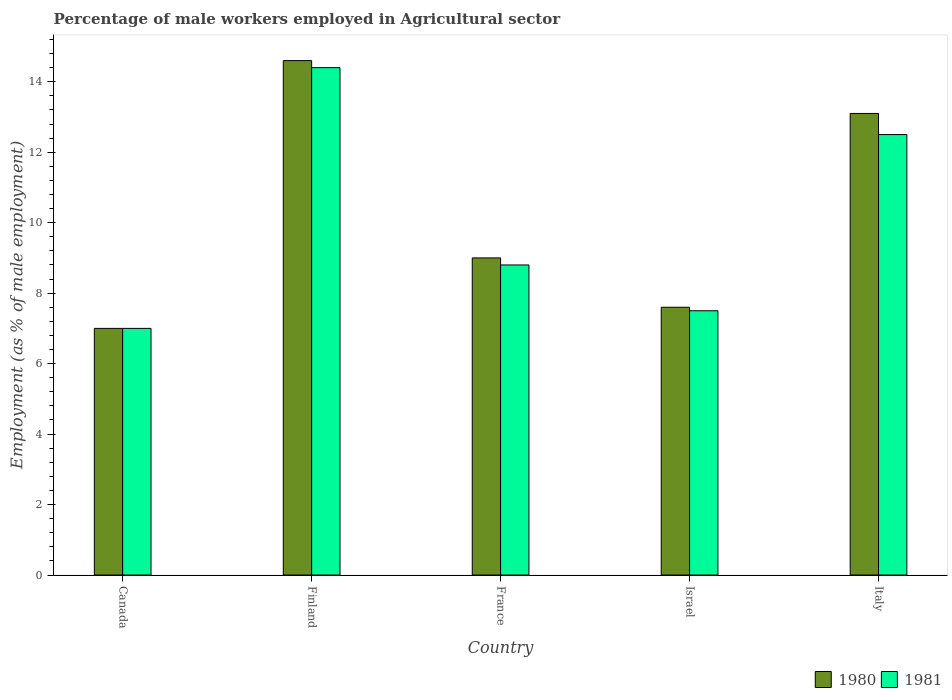How many different coloured bars are there?
Provide a succinct answer. 2. Are the number of bars per tick equal to the number of legend labels?
Provide a succinct answer. Yes. Are the number of bars on each tick of the X-axis equal?
Your answer should be compact. Yes. How many bars are there on the 2nd tick from the left?
Give a very brief answer. 2. How many bars are there on the 3rd tick from the right?
Keep it short and to the point. 2. In how many cases, is the number of bars for a given country not equal to the number of legend labels?
Make the answer very short. 0. Across all countries, what is the maximum percentage of male workers employed in Agricultural sector in 1980?
Your response must be concise. 14.6. In which country was the percentage of male workers employed in Agricultural sector in 1981 maximum?
Make the answer very short. Finland. What is the total percentage of male workers employed in Agricultural sector in 1981 in the graph?
Your answer should be compact. 50.2. What is the difference between the percentage of male workers employed in Agricultural sector in 1980 in Canada and that in France?
Offer a terse response. -2. What is the difference between the percentage of male workers employed in Agricultural sector in 1980 in Israel and the percentage of male workers employed in Agricultural sector in 1981 in Italy?
Give a very brief answer. -4.9. What is the average percentage of male workers employed in Agricultural sector in 1980 per country?
Your answer should be compact. 10.26. What is the difference between the percentage of male workers employed in Agricultural sector of/in 1981 and percentage of male workers employed in Agricultural sector of/in 1980 in Italy?
Your answer should be compact. -0.6. In how many countries, is the percentage of male workers employed in Agricultural sector in 1981 greater than 0.8 %?
Ensure brevity in your answer.  5. What is the ratio of the percentage of male workers employed in Agricultural sector in 1981 in France to that in Israel?
Keep it short and to the point. 1.17. What is the difference between the highest and the second highest percentage of male workers employed in Agricultural sector in 1980?
Ensure brevity in your answer.  -4.1. What is the difference between the highest and the lowest percentage of male workers employed in Agricultural sector in 1980?
Ensure brevity in your answer.  7.6. In how many countries, is the percentage of male workers employed in Agricultural sector in 1981 greater than the average percentage of male workers employed in Agricultural sector in 1981 taken over all countries?
Your response must be concise. 2. How many bars are there?
Your answer should be compact. 10. Are all the bars in the graph horizontal?
Keep it short and to the point. No. How many countries are there in the graph?
Your response must be concise. 5. Are the values on the major ticks of Y-axis written in scientific E-notation?
Your answer should be compact. No. Does the graph contain grids?
Offer a terse response. No. Where does the legend appear in the graph?
Offer a terse response. Bottom right. How many legend labels are there?
Ensure brevity in your answer.  2. What is the title of the graph?
Your answer should be compact. Percentage of male workers employed in Agricultural sector. What is the label or title of the Y-axis?
Your answer should be very brief. Employment (as % of male employment). What is the Employment (as % of male employment) of 1980 in Canada?
Ensure brevity in your answer.  7. What is the Employment (as % of male employment) in 1981 in Canada?
Your response must be concise. 7. What is the Employment (as % of male employment) in 1980 in Finland?
Offer a terse response. 14.6. What is the Employment (as % of male employment) of 1981 in Finland?
Your response must be concise. 14.4. What is the Employment (as % of male employment) in 1981 in France?
Provide a short and direct response. 8.8. What is the Employment (as % of male employment) of 1980 in Israel?
Provide a succinct answer. 7.6. What is the Employment (as % of male employment) of 1981 in Israel?
Provide a succinct answer. 7.5. What is the Employment (as % of male employment) in 1980 in Italy?
Make the answer very short. 13.1. Across all countries, what is the maximum Employment (as % of male employment) in 1980?
Your answer should be compact. 14.6. Across all countries, what is the maximum Employment (as % of male employment) in 1981?
Your answer should be very brief. 14.4. Across all countries, what is the minimum Employment (as % of male employment) of 1980?
Offer a very short reply. 7. Across all countries, what is the minimum Employment (as % of male employment) in 1981?
Your response must be concise. 7. What is the total Employment (as % of male employment) of 1980 in the graph?
Your response must be concise. 51.3. What is the total Employment (as % of male employment) of 1981 in the graph?
Ensure brevity in your answer.  50.2. What is the difference between the Employment (as % of male employment) in 1981 in Canada and that in Finland?
Your answer should be compact. -7.4. What is the difference between the Employment (as % of male employment) of 1981 in Canada and that in Israel?
Provide a succinct answer. -0.5. What is the difference between the Employment (as % of male employment) in 1981 in Canada and that in Italy?
Your answer should be compact. -5.5. What is the difference between the Employment (as % of male employment) of 1980 in Finland and that in France?
Ensure brevity in your answer.  5.6. What is the difference between the Employment (as % of male employment) of 1981 in Finland and that in Israel?
Make the answer very short. 6.9. What is the difference between the Employment (as % of male employment) of 1981 in France and that in Israel?
Make the answer very short. 1.3. What is the difference between the Employment (as % of male employment) of 1981 in France and that in Italy?
Provide a succinct answer. -3.7. What is the difference between the Employment (as % of male employment) of 1980 in Israel and that in Italy?
Make the answer very short. -5.5. What is the difference between the Employment (as % of male employment) in 1980 in Canada and the Employment (as % of male employment) in 1981 in Israel?
Keep it short and to the point. -0.5. What is the difference between the Employment (as % of male employment) in 1980 in Finland and the Employment (as % of male employment) in 1981 in France?
Offer a terse response. 5.8. What is the difference between the Employment (as % of male employment) of 1980 in France and the Employment (as % of male employment) of 1981 in Israel?
Provide a succinct answer. 1.5. What is the difference between the Employment (as % of male employment) of 1980 in France and the Employment (as % of male employment) of 1981 in Italy?
Offer a terse response. -3.5. What is the average Employment (as % of male employment) in 1980 per country?
Make the answer very short. 10.26. What is the average Employment (as % of male employment) of 1981 per country?
Ensure brevity in your answer.  10.04. What is the difference between the Employment (as % of male employment) in 1980 and Employment (as % of male employment) in 1981 in Finland?
Ensure brevity in your answer.  0.2. What is the difference between the Employment (as % of male employment) in 1980 and Employment (as % of male employment) in 1981 in Israel?
Keep it short and to the point. 0.1. What is the difference between the Employment (as % of male employment) in 1980 and Employment (as % of male employment) in 1981 in Italy?
Provide a short and direct response. 0.6. What is the ratio of the Employment (as % of male employment) in 1980 in Canada to that in Finland?
Keep it short and to the point. 0.48. What is the ratio of the Employment (as % of male employment) of 1981 in Canada to that in Finland?
Offer a very short reply. 0.49. What is the ratio of the Employment (as % of male employment) of 1981 in Canada to that in France?
Give a very brief answer. 0.8. What is the ratio of the Employment (as % of male employment) of 1980 in Canada to that in Israel?
Your answer should be very brief. 0.92. What is the ratio of the Employment (as % of male employment) of 1981 in Canada to that in Israel?
Ensure brevity in your answer.  0.93. What is the ratio of the Employment (as % of male employment) of 1980 in Canada to that in Italy?
Give a very brief answer. 0.53. What is the ratio of the Employment (as % of male employment) of 1981 in Canada to that in Italy?
Your answer should be very brief. 0.56. What is the ratio of the Employment (as % of male employment) of 1980 in Finland to that in France?
Give a very brief answer. 1.62. What is the ratio of the Employment (as % of male employment) in 1981 in Finland to that in France?
Provide a succinct answer. 1.64. What is the ratio of the Employment (as % of male employment) of 1980 in Finland to that in Israel?
Provide a short and direct response. 1.92. What is the ratio of the Employment (as % of male employment) of 1981 in Finland to that in Israel?
Give a very brief answer. 1.92. What is the ratio of the Employment (as % of male employment) in 1980 in Finland to that in Italy?
Your answer should be very brief. 1.11. What is the ratio of the Employment (as % of male employment) of 1981 in Finland to that in Italy?
Your answer should be very brief. 1.15. What is the ratio of the Employment (as % of male employment) of 1980 in France to that in Israel?
Your answer should be very brief. 1.18. What is the ratio of the Employment (as % of male employment) of 1981 in France to that in Israel?
Make the answer very short. 1.17. What is the ratio of the Employment (as % of male employment) of 1980 in France to that in Italy?
Offer a terse response. 0.69. What is the ratio of the Employment (as % of male employment) of 1981 in France to that in Italy?
Ensure brevity in your answer.  0.7. What is the ratio of the Employment (as % of male employment) of 1980 in Israel to that in Italy?
Offer a very short reply. 0.58. What is the ratio of the Employment (as % of male employment) in 1981 in Israel to that in Italy?
Offer a terse response. 0.6. What is the difference between the highest and the second highest Employment (as % of male employment) in 1980?
Keep it short and to the point. 1.5. What is the difference between the highest and the lowest Employment (as % of male employment) of 1981?
Keep it short and to the point. 7.4. 